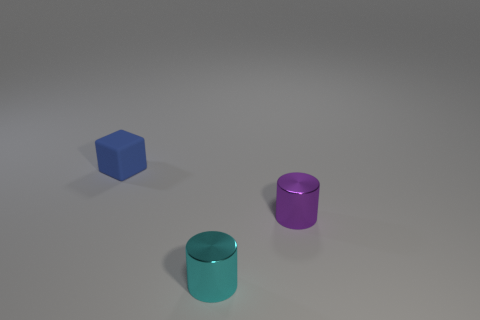Subtract all brown cylinders. Subtract all green cubes. How many cylinders are left? 2 Add 3 purple metallic things. How many objects exist? 6 Subtract all cubes. How many objects are left? 2 Add 1 tiny cyan metallic blocks. How many tiny cyan metallic blocks exist? 1 Subtract 0 green blocks. How many objects are left? 3 Subtract all small green blocks. Subtract all metal cylinders. How many objects are left? 1 Add 1 tiny purple metallic cylinders. How many tiny purple metallic cylinders are left? 2 